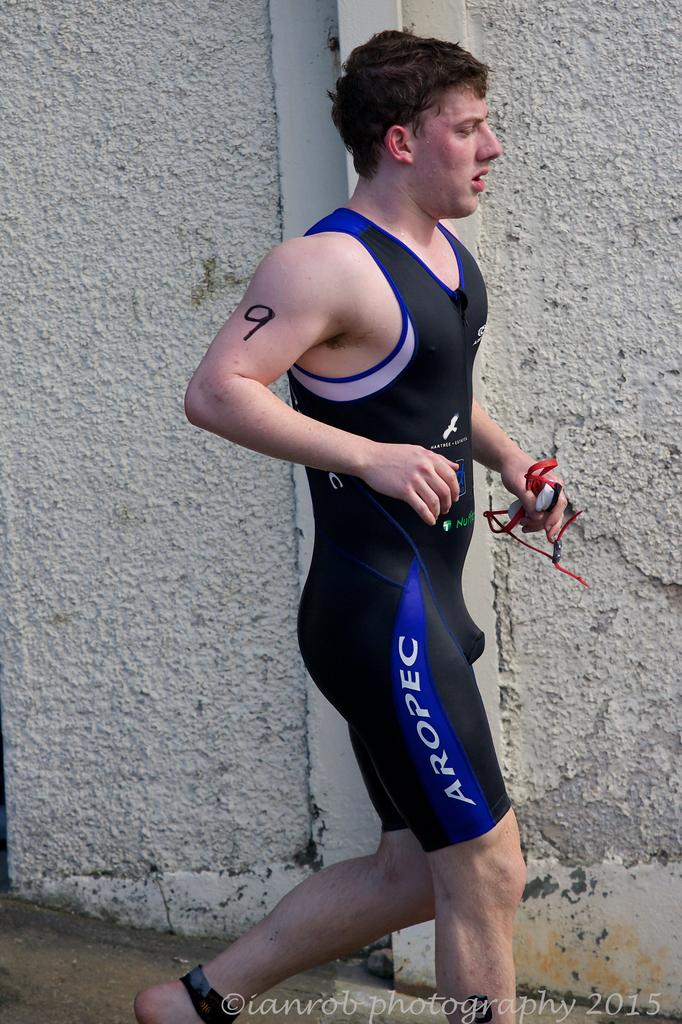<image>
Share a concise interpretation of the image provided. A man in sports gear with a number 9 on his arm 